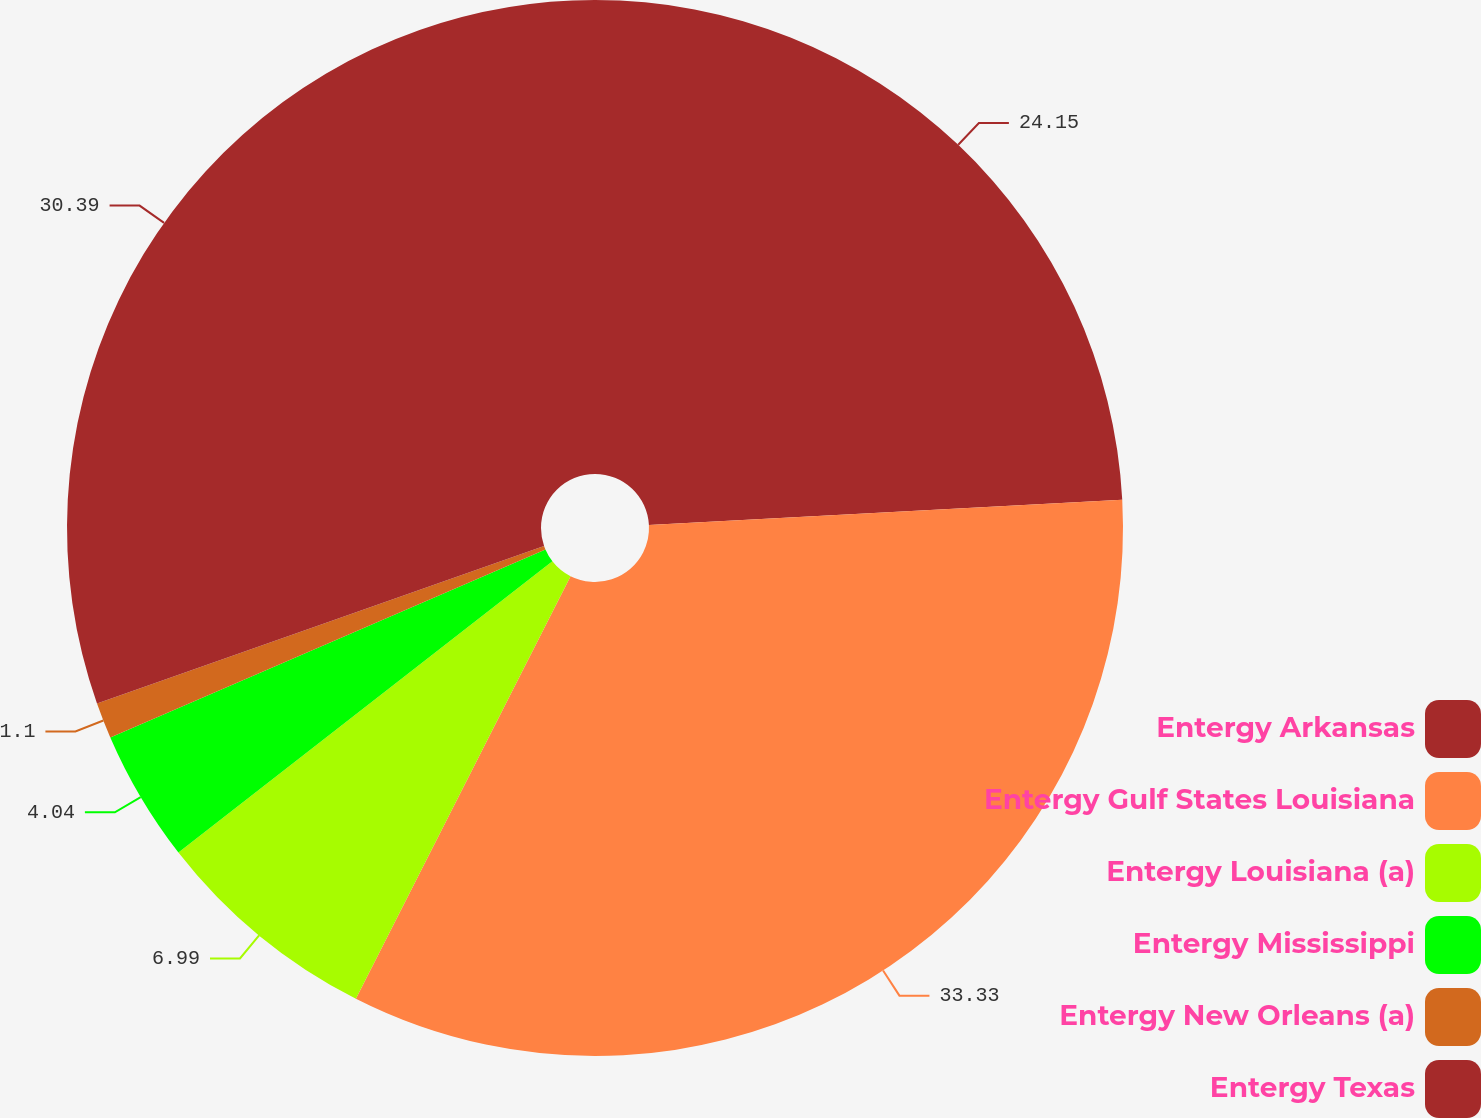Convert chart to OTSL. <chart><loc_0><loc_0><loc_500><loc_500><pie_chart><fcel>Entergy Arkansas<fcel>Entergy Gulf States Louisiana<fcel>Entergy Louisiana (a)<fcel>Entergy Mississippi<fcel>Entergy New Orleans (a)<fcel>Entergy Texas<nl><fcel>24.15%<fcel>33.33%<fcel>6.99%<fcel>4.04%<fcel>1.1%<fcel>30.39%<nl></chart> 